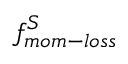<formula> <loc_0><loc_0><loc_500><loc_500>f _ { m o m - l o s s } ^ { S }</formula> 